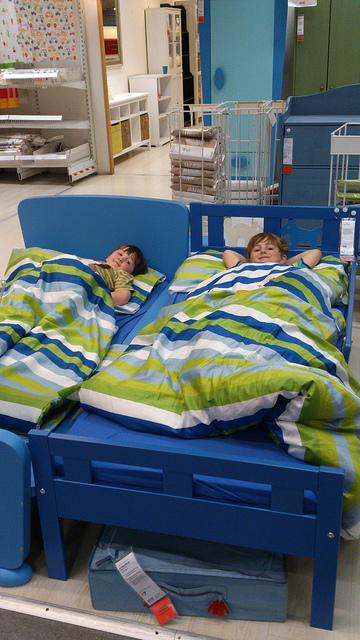Where are the beds that the boys are lying on? store 